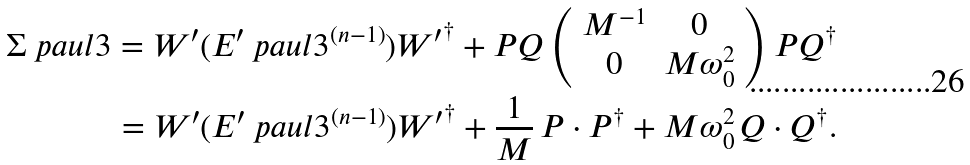<formula> <loc_0><loc_0><loc_500><loc_500>\Sigma \ p a u l { 3 } = W ^ { \prime } ( E ^ { \prime } \ p a u l { 3 } ^ { ( n - 1 ) } ) { W ^ { \prime } } ^ { \dag } + P Q \left ( \begin{array} { c c } M ^ { - 1 } & 0 \\ 0 & M \omega _ { 0 } ^ { 2 } \end{array} \right ) P Q ^ { \dag } \\ = W ^ { \prime } ( E ^ { \prime } \ p a u l { 3 } ^ { ( n - 1 ) } ) { W ^ { \prime } } ^ { \dag } + \frac { 1 } { M } \, P \cdot P ^ { \dag } + M \omega _ { 0 } ^ { 2 } \, Q \cdot Q ^ { \dag } .</formula> 